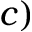Convert formula to latex. <formula><loc_0><loc_0><loc_500><loc_500>c )</formula> 